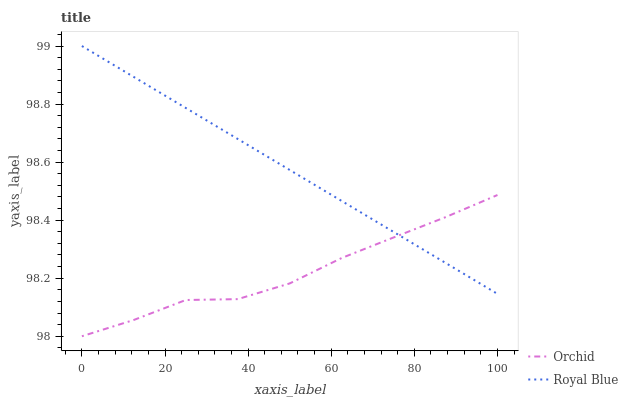Does Orchid have the maximum area under the curve?
Answer yes or no. No. Is Orchid the smoothest?
Answer yes or no. No. Does Orchid have the highest value?
Answer yes or no. No. 